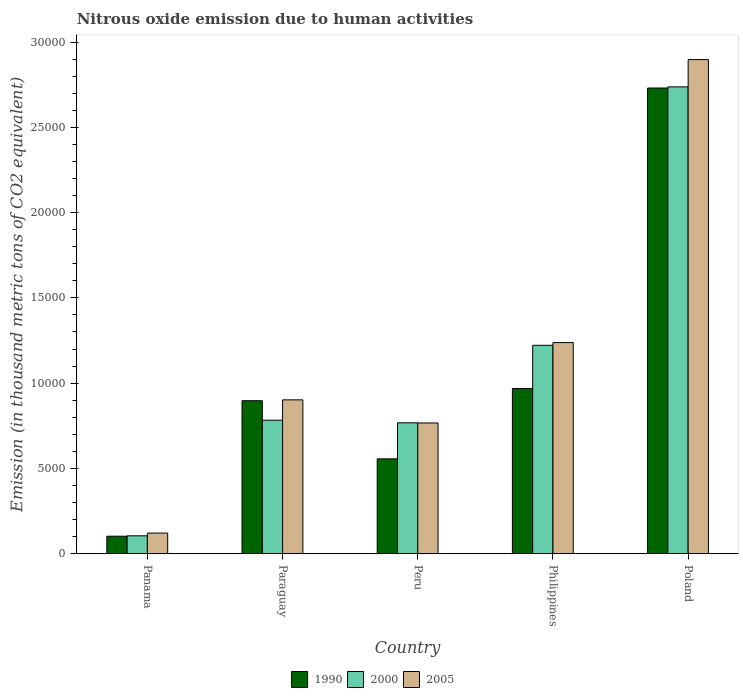How many different coloured bars are there?
Make the answer very short. 3. Are the number of bars per tick equal to the number of legend labels?
Make the answer very short. Yes. Are the number of bars on each tick of the X-axis equal?
Make the answer very short. Yes. How many bars are there on the 3rd tick from the left?
Provide a short and direct response. 3. How many bars are there on the 1st tick from the right?
Your answer should be very brief. 3. What is the label of the 4th group of bars from the left?
Your response must be concise. Philippines. In how many cases, is the number of bars for a given country not equal to the number of legend labels?
Keep it short and to the point. 0. What is the amount of nitrous oxide emitted in 2005 in Philippines?
Keep it short and to the point. 1.24e+04. Across all countries, what is the maximum amount of nitrous oxide emitted in 2000?
Your answer should be compact. 2.74e+04. Across all countries, what is the minimum amount of nitrous oxide emitted in 1990?
Keep it short and to the point. 1023.3. In which country was the amount of nitrous oxide emitted in 2000 minimum?
Provide a succinct answer. Panama. What is the total amount of nitrous oxide emitted in 2000 in the graph?
Make the answer very short. 5.61e+04. What is the difference between the amount of nitrous oxide emitted in 1990 in Panama and that in Peru?
Your response must be concise. -4536. What is the difference between the amount of nitrous oxide emitted in 1990 in Poland and the amount of nitrous oxide emitted in 2005 in Peru?
Ensure brevity in your answer.  1.96e+04. What is the average amount of nitrous oxide emitted in 2000 per country?
Provide a succinct answer. 1.12e+04. What is the difference between the amount of nitrous oxide emitted of/in 2000 and amount of nitrous oxide emitted of/in 2005 in Paraguay?
Provide a succinct answer. -1193.4. In how many countries, is the amount of nitrous oxide emitted in 2005 greater than 2000 thousand metric tons?
Provide a succinct answer. 4. What is the ratio of the amount of nitrous oxide emitted in 2000 in Panama to that in Peru?
Keep it short and to the point. 0.14. Is the amount of nitrous oxide emitted in 2005 in Peru less than that in Philippines?
Offer a very short reply. Yes. What is the difference between the highest and the second highest amount of nitrous oxide emitted in 1990?
Your response must be concise. -714.1. What is the difference between the highest and the lowest amount of nitrous oxide emitted in 2005?
Your response must be concise. 2.78e+04. In how many countries, is the amount of nitrous oxide emitted in 2000 greater than the average amount of nitrous oxide emitted in 2000 taken over all countries?
Offer a very short reply. 2. Is the sum of the amount of nitrous oxide emitted in 2005 in Panama and Philippines greater than the maximum amount of nitrous oxide emitted in 2000 across all countries?
Offer a terse response. No. What does the 1st bar from the right in Paraguay represents?
Keep it short and to the point. 2005. Is it the case that in every country, the sum of the amount of nitrous oxide emitted in 2000 and amount of nitrous oxide emitted in 1990 is greater than the amount of nitrous oxide emitted in 2005?
Your response must be concise. Yes. Are all the bars in the graph horizontal?
Your answer should be compact. No. Are the values on the major ticks of Y-axis written in scientific E-notation?
Make the answer very short. No. Does the graph contain any zero values?
Your answer should be very brief. No. What is the title of the graph?
Your answer should be very brief. Nitrous oxide emission due to human activities. Does "1977" appear as one of the legend labels in the graph?
Make the answer very short. No. What is the label or title of the Y-axis?
Provide a short and direct response. Emission (in thousand metric tons of CO2 equivalent). What is the Emission (in thousand metric tons of CO2 equivalent) of 1990 in Panama?
Provide a succinct answer. 1023.3. What is the Emission (in thousand metric tons of CO2 equivalent) of 2000 in Panama?
Keep it short and to the point. 1046.4. What is the Emission (in thousand metric tons of CO2 equivalent) in 2005 in Panama?
Ensure brevity in your answer.  1207.1. What is the Emission (in thousand metric tons of CO2 equivalent) of 1990 in Paraguay?
Your answer should be compact. 8968.7. What is the Emission (in thousand metric tons of CO2 equivalent) in 2000 in Paraguay?
Your response must be concise. 7826.3. What is the Emission (in thousand metric tons of CO2 equivalent) in 2005 in Paraguay?
Your answer should be compact. 9019.7. What is the Emission (in thousand metric tons of CO2 equivalent) of 1990 in Peru?
Offer a very short reply. 5559.3. What is the Emission (in thousand metric tons of CO2 equivalent) in 2000 in Peru?
Keep it short and to the point. 7673.9. What is the Emission (in thousand metric tons of CO2 equivalent) of 2005 in Peru?
Keep it short and to the point. 7664.2. What is the Emission (in thousand metric tons of CO2 equivalent) of 1990 in Philippines?
Provide a short and direct response. 9682.8. What is the Emission (in thousand metric tons of CO2 equivalent) in 2000 in Philippines?
Keep it short and to the point. 1.22e+04. What is the Emission (in thousand metric tons of CO2 equivalent) of 2005 in Philippines?
Make the answer very short. 1.24e+04. What is the Emission (in thousand metric tons of CO2 equivalent) in 1990 in Poland?
Provide a short and direct response. 2.73e+04. What is the Emission (in thousand metric tons of CO2 equivalent) in 2000 in Poland?
Give a very brief answer. 2.74e+04. What is the Emission (in thousand metric tons of CO2 equivalent) in 2005 in Poland?
Give a very brief answer. 2.90e+04. Across all countries, what is the maximum Emission (in thousand metric tons of CO2 equivalent) in 1990?
Your answer should be compact. 2.73e+04. Across all countries, what is the maximum Emission (in thousand metric tons of CO2 equivalent) of 2000?
Your answer should be compact. 2.74e+04. Across all countries, what is the maximum Emission (in thousand metric tons of CO2 equivalent) of 2005?
Your answer should be compact. 2.90e+04. Across all countries, what is the minimum Emission (in thousand metric tons of CO2 equivalent) in 1990?
Offer a terse response. 1023.3. Across all countries, what is the minimum Emission (in thousand metric tons of CO2 equivalent) in 2000?
Offer a very short reply. 1046.4. Across all countries, what is the minimum Emission (in thousand metric tons of CO2 equivalent) of 2005?
Ensure brevity in your answer.  1207.1. What is the total Emission (in thousand metric tons of CO2 equivalent) of 1990 in the graph?
Your answer should be very brief. 5.25e+04. What is the total Emission (in thousand metric tons of CO2 equivalent) of 2000 in the graph?
Offer a terse response. 5.61e+04. What is the total Emission (in thousand metric tons of CO2 equivalent) in 2005 in the graph?
Your answer should be very brief. 5.92e+04. What is the difference between the Emission (in thousand metric tons of CO2 equivalent) in 1990 in Panama and that in Paraguay?
Your response must be concise. -7945.4. What is the difference between the Emission (in thousand metric tons of CO2 equivalent) in 2000 in Panama and that in Paraguay?
Your response must be concise. -6779.9. What is the difference between the Emission (in thousand metric tons of CO2 equivalent) of 2005 in Panama and that in Paraguay?
Keep it short and to the point. -7812.6. What is the difference between the Emission (in thousand metric tons of CO2 equivalent) of 1990 in Panama and that in Peru?
Your answer should be compact. -4536. What is the difference between the Emission (in thousand metric tons of CO2 equivalent) of 2000 in Panama and that in Peru?
Provide a short and direct response. -6627.5. What is the difference between the Emission (in thousand metric tons of CO2 equivalent) of 2005 in Panama and that in Peru?
Ensure brevity in your answer.  -6457.1. What is the difference between the Emission (in thousand metric tons of CO2 equivalent) in 1990 in Panama and that in Philippines?
Keep it short and to the point. -8659.5. What is the difference between the Emission (in thousand metric tons of CO2 equivalent) in 2000 in Panama and that in Philippines?
Give a very brief answer. -1.12e+04. What is the difference between the Emission (in thousand metric tons of CO2 equivalent) in 2005 in Panama and that in Philippines?
Provide a succinct answer. -1.12e+04. What is the difference between the Emission (in thousand metric tons of CO2 equivalent) of 1990 in Panama and that in Poland?
Your response must be concise. -2.63e+04. What is the difference between the Emission (in thousand metric tons of CO2 equivalent) of 2000 in Panama and that in Poland?
Ensure brevity in your answer.  -2.63e+04. What is the difference between the Emission (in thousand metric tons of CO2 equivalent) of 2005 in Panama and that in Poland?
Offer a very short reply. -2.78e+04. What is the difference between the Emission (in thousand metric tons of CO2 equivalent) of 1990 in Paraguay and that in Peru?
Give a very brief answer. 3409.4. What is the difference between the Emission (in thousand metric tons of CO2 equivalent) of 2000 in Paraguay and that in Peru?
Ensure brevity in your answer.  152.4. What is the difference between the Emission (in thousand metric tons of CO2 equivalent) in 2005 in Paraguay and that in Peru?
Make the answer very short. 1355.5. What is the difference between the Emission (in thousand metric tons of CO2 equivalent) of 1990 in Paraguay and that in Philippines?
Your answer should be very brief. -714.1. What is the difference between the Emission (in thousand metric tons of CO2 equivalent) of 2000 in Paraguay and that in Philippines?
Make the answer very short. -4392.8. What is the difference between the Emission (in thousand metric tons of CO2 equivalent) in 2005 in Paraguay and that in Philippines?
Offer a very short reply. -3358.4. What is the difference between the Emission (in thousand metric tons of CO2 equivalent) in 1990 in Paraguay and that in Poland?
Make the answer very short. -1.83e+04. What is the difference between the Emission (in thousand metric tons of CO2 equivalent) of 2000 in Paraguay and that in Poland?
Ensure brevity in your answer.  -1.95e+04. What is the difference between the Emission (in thousand metric tons of CO2 equivalent) in 2005 in Paraguay and that in Poland?
Make the answer very short. -2.00e+04. What is the difference between the Emission (in thousand metric tons of CO2 equivalent) in 1990 in Peru and that in Philippines?
Ensure brevity in your answer.  -4123.5. What is the difference between the Emission (in thousand metric tons of CO2 equivalent) of 2000 in Peru and that in Philippines?
Your answer should be compact. -4545.2. What is the difference between the Emission (in thousand metric tons of CO2 equivalent) of 2005 in Peru and that in Philippines?
Provide a short and direct response. -4713.9. What is the difference between the Emission (in thousand metric tons of CO2 equivalent) of 1990 in Peru and that in Poland?
Your answer should be compact. -2.17e+04. What is the difference between the Emission (in thousand metric tons of CO2 equivalent) in 2000 in Peru and that in Poland?
Offer a terse response. -1.97e+04. What is the difference between the Emission (in thousand metric tons of CO2 equivalent) of 2005 in Peru and that in Poland?
Your answer should be compact. -2.13e+04. What is the difference between the Emission (in thousand metric tons of CO2 equivalent) of 1990 in Philippines and that in Poland?
Make the answer very short. -1.76e+04. What is the difference between the Emission (in thousand metric tons of CO2 equivalent) in 2000 in Philippines and that in Poland?
Your answer should be very brief. -1.52e+04. What is the difference between the Emission (in thousand metric tons of CO2 equivalent) of 2005 in Philippines and that in Poland?
Ensure brevity in your answer.  -1.66e+04. What is the difference between the Emission (in thousand metric tons of CO2 equivalent) in 1990 in Panama and the Emission (in thousand metric tons of CO2 equivalent) in 2000 in Paraguay?
Your response must be concise. -6803. What is the difference between the Emission (in thousand metric tons of CO2 equivalent) of 1990 in Panama and the Emission (in thousand metric tons of CO2 equivalent) of 2005 in Paraguay?
Provide a short and direct response. -7996.4. What is the difference between the Emission (in thousand metric tons of CO2 equivalent) in 2000 in Panama and the Emission (in thousand metric tons of CO2 equivalent) in 2005 in Paraguay?
Ensure brevity in your answer.  -7973.3. What is the difference between the Emission (in thousand metric tons of CO2 equivalent) in 1990 in Panama and the Emission (in thousand metric tons of CO2 equivalent) in 2000 in Peru?
Provide a short and direct response. -6650.6. What is the difference between the Emission (in thousand metric tons of CO2 equivalent) in 1990 in Panama and the Emission (in thousand metric tons of CO2 equivalent) in 2005 in Peru?
Keep it short and to the point. -6640.9. What is the difference between the Emission (in thousand metric tons of CO2 equivalent) of 2000 in Panama and the Emission (in thousand metric tons of CO2 equivalent) of 2005 in Peru?
Keep it short and to the point. -6617.8. What is the difference between the Emission (in thousand metric tons of CO2 equivalent) of 1990 in Panama and the Emission (in thousand metric tons of CO2 equivalent) of 2000 in Philippines?
Make the answer very short. -1.12e+04. What is the difference between the Emission (in thousand metric tons of CO2 equivalent) of 1990 in Panama and the Emission (in thousand metric tons of CO2 equivalent) of 2005 in Philippines?
Your answer should be very brief. -1.14e+04. What is the difference between the Emission (in thousand metric tons of CO2 equivalent) in 2000 in Panama and the Emission (in thousand metric tons of CO2 equivalent) in 2005 in Philippines?
Provide a succinct answer. -1.13e+04. What is the difference between the Emission (in thousand metric tons of CO2 equivalent) of 1990 in Panama and the Emission (in thousand metric tons of CO2 equivalent) of 2000 in Poland?
Your response must be concise. -2.64e+04. What is the difference between the Emission (in thousand metric tons of CO2 equivalent) of 1990 in Panama and the Emission (in thousand metric tons of CO2 equivalent) of 2005 in Poland?
Your answer should be very brief. -2.80e+04. What is the difference between the Emission (in thousand metric tons of CO2 equivalent) in 2000 in Panama and the Emission (in thousand metric tons of CO2 equivalent) in 2005 in Poland?
Your answer should be compact. -2.79e+04. What is the difference between the Emission (in thousand metric tons of CO2 equivalent) of 1990 in Paraguay and the Emission (in thousand metric tons of CO2 equivalent) of 2000 in Peru?
Keep it short and to the point. 1294.8. What is the difference between the Emission (in thousand metric tons of CO2 equivalent) of 1990 in Paraguay and the Emission (in thousand metric tons of CO2 equivalent) of 2005 in Peru?
Ensure brevity in your answer.  1304.5. What is the difference between the Emission (in thousand metric tons of CO2 equivalent) of 2000 in Paraguay and the Emission (in thousand metric tons of CO2 equivalent) of 2005 in Peru?
Provide a short and direct response. 162.1. What is the difference between the Emission (in thousand metric tons of CO2 equivalent) of 1990 in Paraguay and the Emission (in thousand metric tons of CO2 equivalent) of 2000 in Philippines?
Ensure brevity in your answer.  -3250.4. What is the difference between the Emission (in thousand metric tons of CO2 equivalent) of 1990 in Paraguay and the Emission (in thousand metric tons of CO2 equivalent) of 2005 in Philippines?
Give a very brief answer. -3409.4. What is the difference between the Emission (in thousand metric tons of CO2 equivalent) of 2000 in Paraguay and the Emission (in thousand metric tons of CO2 equivalent) of 2005 in Philippines?
Your answer should be compact. -4551.8. What is the difference between the Emission (in thousand metric tons of CO2 equivalent) in 1990 in Paraguay and the Emission (in thousand metric tons of CO2 equivalent) in 2000 in Poland?
Your answer should be very brief. -1.84e+04. What is the difference between the Emission (in thousand metric tons of CO2 equivalent) in 1990 in Paraguay and the Emission (in thousand metric tons of CO2 equivalent) in 2005 in Poland?
Make the answer very short. -2.00e+04. What is the difference between the Emission (in thousand metric tons of CO2 equivalent) of 2000 in Paraguay and the Emission (in thousand metric tons of CO2 equivalent) of 2005 in Poland?
Your response must be concise. -2.11e+04. What is the difference between the Emission (in thousand metric tons of CO2 equivalent) in 1990 in Peru and the Emission (in thousand metric tons of CO2 equivalent) in 2000 in Philippines?
Your response must be concise. -6659.8. What is the difference between the Emission (in thousand metric tons of CO2 equivalent) of 1990 in Peru and the Emission (in thousand metric tons of CO2 equivalent) of 2005 in Philippines?
Give a very brief answer. -6818.8. What is the difference between the Emission (in thousand metric tons of CO2 equivalent) of 2000 in Peru and the Emission (in thousand metric tons of CO2 equivalent) of 2005 in Philippines?
Your answer should be very brief. -4704.2. What is the difference between the Emission (in thousand metric tons of CO2 equivalent) of 1990 in Peru and the Emission (in thousand metric tons of CO2 equivalent) of 2000 in Poland?
Ensure brevity in your answer.  -2.18e+04. What is the difference between the Emission (in thousand metric tons of CO2 equivalent) of 1990 in Peru and the Emission (in thousand metric tons of CO2 equivalent) of 2005 in Poland?
Provide a short and direct response. -2.34e+04. What is the difference between the Emission (in thousand metric tons of CO2 equivalent) of 2000 in Peru and the Emission (in thousand metric tons of CO2 equivalent) of 2005 in Poland?
Keep it short and to the point. -2.13e+04. What is the difference between the Emission (in thousand metric tons of CO2 equivalent) of 1990 in Philippines and the Emission (in thousand metric tons of CO2 equivalent) of 2000 in Poland?
Your answer should be very brief. -1.77e+04. What is the difference between the Emission (in thousand metric tons of CO2 equivalent) of 1990 in Philippines and the Emission (in thousand metric tons of CO2 equivalent) of 2005 in Poland?
Your answer should be very brief. -1.93e+04. What is the difference between the Emission (in thousand metric tons of CO2 equivalent) of 2000 in Philippines and the Emission (in thousand metric tons of CO2 equivalent) of 2005 in Poland?
Ensure brevity in your answer.  -1.68e+04. What is the average Emission (in thousand metric tons of CO2 equivalent) of 1990 per country?
Offer a terse response. 1.05e+04. What is the average Emission (in thousand metric tons of CO2 equivalent) of 2000 per country?
Give a very brief answer. 1.12e+04. What is the average Emission (in thousand metric tons of CO2 equivalent) in 2005 per country?
Provide a short and direct response. 1.18e+04. What is the difference between the Emission (in thousand metric tons of CO2 equivalent) of 1990 and Emission (in thousand metric tons of CO2 equivalent) of 2000 in Panama?
Offer a terse response. -23.1. What is the difference between the Emission (in thousand metric tons of CO2 equivalent) in 1990 and Emission (in thousand metric tons of CO2 equivalent) in 2005 in Panama?
Provide a short and direct response. -183.8. What is the difference between the Emission (in thousand metric tons of CO2 equivalent) of 2000 and Emission (in thousand metric tons of CO2 equivalent) of 2005 in Panama?
Ensure brevity in your answer.  -160.7. What is the difference between the Emission (in thousand metric tons of CO2 equivalent) of 1990 and Emission (in thousand metric tons of CO2 equivalent) of 2000 in Paraguay?
Your response must be concise. 1142.4. What is the difference between the Emission (in thousand metric tons of CO2 equivalent) of 1990 and Emission (in thousand metric tons of CO2 equivalent) of 2005 in Paraguay?
Your answer should be compact. -51. What is the difference between the Emission (in thousand metric tons of CO2 equivalent) in 2000 and Emission (in thousand metric tons of CO2 equivalent) in 2005 in Paraguay?
Your response must be concise. -1193.4. What is the difference between the Emission (in thousand metric tons of CO2 equivalent) in 1990 and Emission (in thousand metric tons of CO2 equivalent) in 2000 in Peru?
Your answer should be compact. -2114.6. What is the difference between the Emission (in thousand metric tons of CO2 equivalent) in 1990 and Emission (in thousand metric tons of CO2 equivalent) in 2005 in Peru?
Make the answer very short. -2104.9. What is the difference between the Emission (in thousand metric tons of CO2 equivalent) in 2000 and Emission (in thousand metric tons of CO2 equivalent) in 2005 in Peru?
Provide a short and direct response. 9.7. What is the difference between the Emission (in thousand metric tons of CO2 equivalent) of 1990 and Emission (in thousand metric tons of CO2 equivalent) of 2000 in Philippines?
Offer a terse response. -2536.3. What is the difference between the Emission (in thousand metric tons of CO2 equivalent) in 1990 and Emission (in thousand metric tons of CO2 equivalent) in 2005 in Philippines?
Make the answer very short. -2695.3. What is the difference between the Emission (in thousand metric tons of CO2 equivalent) in 2000 and Emission (in thousand metric tons of CO2 equivalent) in 2005 in Philippines?
Your response must be concise. -159. What is the difference between the Emission (in thousand metric tons of CO2 equivalent) in 1990 and Emission (in thousand metric tons of CO2 equivalent) in 2000 in Poland?
Offer a terse response. -66.8. What is the difference between the Emission (in thousand metric tons of CO2 equivalent) in 1990 and Emission (in thousand metric tons of CO2 equivalent) in 2005 in Poland?
Offer a terse response. -1667.4. What is the difference between the Emission (in thousand metric tons of CO2 equivalent) of 2000 and Emission (in thousand metric tons of CO2 equivalent) of 2005 in Poland?
Offer a terse response. -1600.6. What is the ratio of the Emission (in thousand metric tons of CO2 equivalent) in 1990 in Panama to that in Paraguay?
Your response must be concise. 0.11. What is the ratio of the Emission (in thousand metric tons of CO2 equivalent) of 2000 in Panama to that in Paraguay?
Your answer should be compact. 0.13. What is the ratio of the Emission (in thousand metric tons of CO2 equivalent) of 2005 in Panama to that in Paraguay?
Your answer should be very brief. 0.13. What is the ratio of the Emission (in thousand metric tons of CO2 equivalent) in 1990 in Panama to that in Peru?
Keep it short and to the point. 0.18. What is the ratio of the Emission (in thousand metric tons of CO2 equivalent) in 2000 in Panama to that in Peru?
Offer a very short reply. 0.14. What is the ratio of the Emission (in thousand metric tons of CO2 equivalent) of 2005 in Panama to that in Peru?
Provide a short and direct response. 0.16. What is the ratio of the Emission (in thousand metric tons of CO2 equivalent) in 1990 in Panama to that in Philippines?
Ensure brevity in your answer.  0.11. What is the ratio of the Emission (in thousand metric tons of CO2 equivalent) in 2000 in Panama to that in Philippines?
Give a very brief answer. 0.09. What is the ratio of the Emission (in thousand metric tons of CO2 equivalent) in 2005 in Panama to that in Philippines?
Your answer should be very brief. 0.1. What is the ratio of the Emission (in thousand metric tons of CO2 equivalent) in 1990 in Panama to that in Poland?
Keep it short and to the point. 0.04. What is the ratio of the Emission (in thousand metric tons of CO2 equivalent) in 2000 in Panama to that in Poland?
Provide a short and direct response. 0.04. What is the ratio of the Emission (in thousand metric tons of CO2 equivalent) in 2005 in Panama to that in Poland?
Offer a terse response. 0.04. What is the ratio of the Emission (in thousand metric tons of CO2 equivalent) of 1990 in Paraguay to that in Peru?
Offer a terse response. 1.61. What is the ratio of the Emission (in thousand metric tons of CO2 equivalent) in 2000 in Paraguay to that in Peru?
Provide a succinct answer. 1.02. What is the ratio of the Emission (in thousand metric tons of CO2 equivalent) in 2005 in Paraguay to that in Peru?
Provide a succinct answer. 1.18. What is the ratio of the Emission (in thousand metric tons of CO2 equivalent) in 1990 in Paraguay to that in Philippines?
Keep it short and to the point. 0.93. What is the ratio of the Emission (in thousand metric tons of CO2 equivalent) in 2000 in Paraguay to that in Philippines?
Your response must be concise. 0.64. What is the ratio of the Emission (in thousand metric tons of CO2 equivalent) of 2005 in Paraguay to that in Philippines?
Keep it short and to the point. 0.73. What is the ratio of the Emission (in thousand metric tons of CO2 equivalent) in 1990 in Paraguay to that in Poland?
Provide a short and direct response. 0.33. What is the ratio of the Emission (in thousand metric tons of CO2 equivalent) in 2000 in Paraguay to that in Poland?
Ensure brevity in your answer.  0.29. What is the ratio of the Emission (in thousand metric tons of CO2 equivalent) in 2005 in Paraguay to that in Poland?
Offer a very short reply. 0.31. What is the ratio of the Emission (in thousand metric tons of CO2 equivalent) in 1990 in Peru to that in Philippines?
Keep it short and to the point. 0.57. What is the ratio of the Emission (in thousand metric tons of CO2 equivalent) in 2000 in Peru to that in Philippines?
Your response must be concise. 0.63. What is the ratio of the Emission (in thousand metric tons of CO2 equivalent) in 2005 in Peru to that in Philippines?
Keep it short and to the point. 0.62. What is the ratio of the Emission (in thousand metric tons of CO2 equivalent) of 1990 in Peru to that in Poland?
Provide a short and direct response. 0.2. What is the ratio of the Emission (in thousand metric tons of CO2 equivalent) in 2000 in Peru to that in Poland?
Give a very brief answer. 0.28. What is the ratio of the Emission (in thousand metric tons of CO2 equivalent) in 2005 in Peru to that in Poland?
Your answer should be very brief. 0.26. What is the ratio of the Emission (in thousand metric tons of CO2 equivalent) of 1990 in Philippines to that in Poland?
Your response must be concise. 0.35. What is the ratio of the Emission (in thousand metric tons of CO2 equivalent) in 2000 in Philippines to that in Poland?
Offer a very short reply. 0.45. What is the ratio of the Emission (in thousand metric tons of CO2 equivalent) of 2005 in Philippines to that in Poland?
Keep it short and to the point. 0.43. What is the difference between the highest and the second highest Emission (in thousand metric tons of CO2 equivalent) in 1990?
Make the answer very short. 1.76e+04. What is the difference between the highest and the second highest Emission (in thousand metric tons of CO2 equivalent) in 2000?
Make the answer very short. 1.52e+04. What is the difference between the highest and the second highest Emission (in thousand metric tons of CO2 equivalent) in 2005?
Your response must be concise. 1.66e+04. What is the difference between the highest and the lowest Emission (in thousand metric tons of CO2 equivalent) of 1990?
Give a very brief answer. 2.63e+04. What is the difference between the highest and the lowest Emission (in thousand metric tons of CO2 equivalent) of 2000?
Offer a terse response. 2.63e+04. What is the difference between the highest and the lowest Emission (in thousand metric tons of CO2 equivalent) of 2005?
Offer a very short reply. 2.78e+04. 